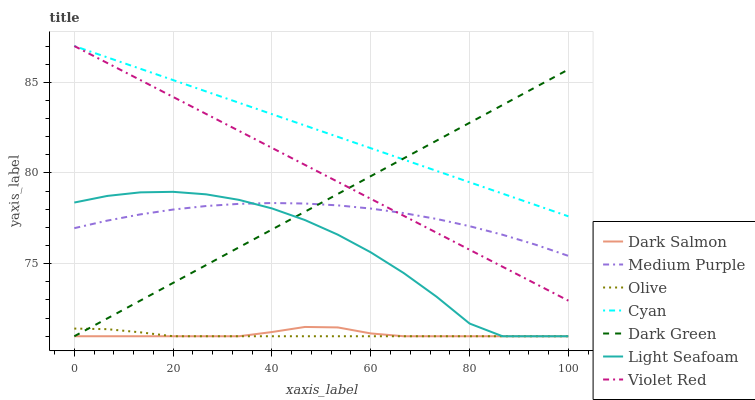Does Olive have the minimum area under the curve?
Answer yes or no. Yes. Does Cyan have the maximum area under the curve?
Answer yes or no. Yes. Does Dark Salmon have the minimum area under the curve?
Answer yes or no. No. Does Dark Salmon have the maximum area under the curve?
Answer yes or no. No. Is Dark Green the smoothest?
Answer yes or no. Yes. Is Light Seafoam the roughest?
Answer yes or no. Yes. Is Dark Salmon the smoothest?
Answer yes or no. No. Is Dark Salmon the roughest?
Answer yes or no. No. Does Dark Salmon have the lowest value?
Answer yes or no. Yes. Does Medium Purple have the lowest value?
Answer yes or no. No. Does Cyan have the highest value?
Answer yes or no. Yes. Does Dark Salmon have the highest value?
Answer yes or no. No. Is Medium Purple less than Cyan?
Answer yes or no. Yes. Is Cyan greater than Light Seafoam?
Answer yes or no. Yes. Does Dark Green intersect Olive?
Answer yes or no. Yes. Is Dark Green less than Olive?
Answer yes or no. No. Is Dark Green greater than Olive?
Answer yes or no. No. Does Medium Purple intersect Cyan?
Answer yes or no. No. 